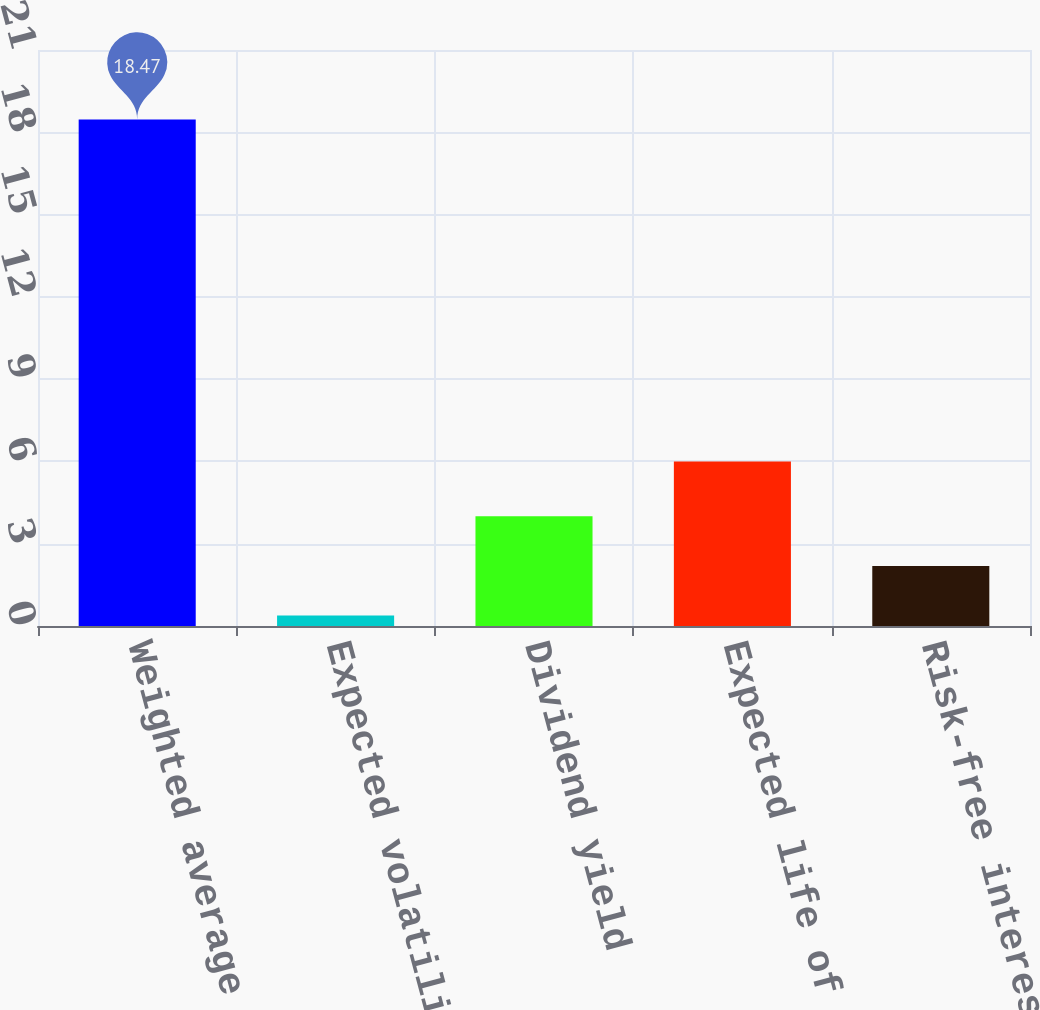<chart> <loc_0><loc_0><loc_500><loc_500><bar_chart><fcel>Weighted average fair value of<fcel>Expected volatility<fcel>Dividend yield<fcel>Expected life of options in<fcel>Risk-free interest rate<nl><fcel>18.47<fcel>0.38<fcel>4<fcel>6<fcel>2.19<nl></chart> 